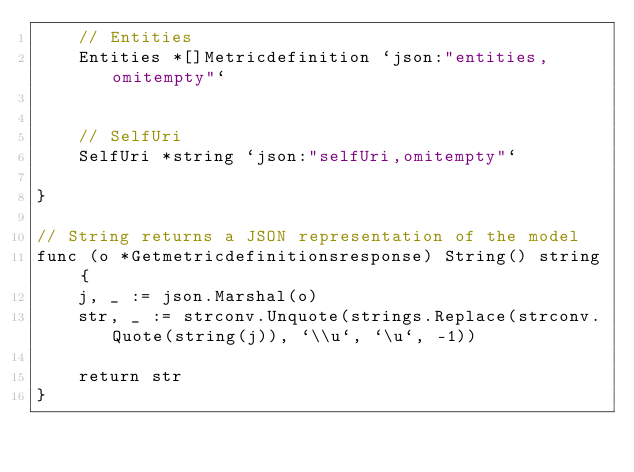<code> <loc_0><loc_0><loc_500><loc_500><_Go_>	// Entities
	Entities *[]Metricdefinition `json:"entities,omitempty"`


	// SelfUri
	SelfUri *string `json:"selfUri,omitempty"`

}

// String returns a JSON representation of the model
func (o *Getmetricdefinitionsresponse) String() string {
	j, _ := json.Marshal(o)
	str, _ := strconv.Unquote(strings.Replace(strconv.Quote(string(j)), `\\u`, `\u`, -1))

	return str
}
</code> 